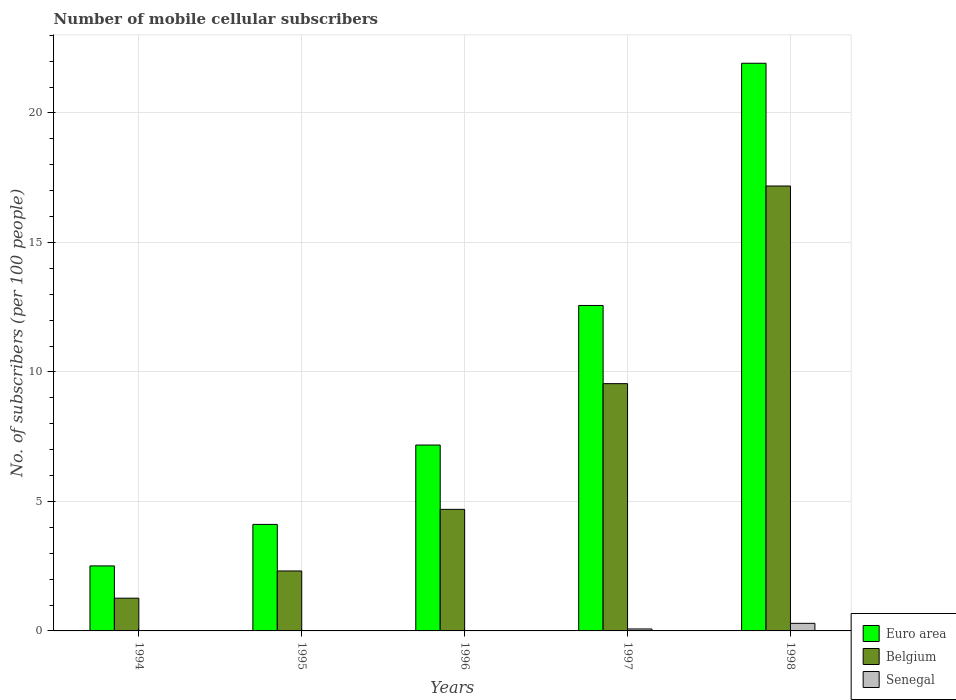How many different coloured bars are there?
Provide a succinct answer. 3. How many groups of bars are there?
Offer a terse response. 5. How many bars are there on the 4th tick from the left?
Your answer should be very brief. 3. How many bars are there on the 5th tick from the right?
Offer a very short reply. 3. What is the label of the 1st group of bars from the left?
Your response must be concise. 1994. What is the number of mobile cellular subscribers in Belgium in 1997?
Provide a short and direct response. 9.55. Across all years, what is the maximum number of mobile cellular subscribers in Senegal?
Provide a short and direct response. 0.29. Across all years, what is the minimum number of mobile cellular subscribers in Senegal?
Ensure brevity in your answer.  0. What is the total number of mobile cellular subscribers in Belgium in the graph?
Offer a very short reply. 35. What is the difference between the number of mobile cellular subscribers in Euro area in 1994 and that in 1998?
Provide a succinct answer. -19.41. What is the difference between the number of mobile cellular subscribers in Belgium in 1998 and the number of mobile cellular subscribers in Euro area in 1996?
Your answer should be compact. 10. What is the average number of mobile cellular subscribers in Euro area per year?
Offer a terse response. 9.66. In the year 1995, what is the difference between the number of mobile cellular subscribers in Belgium and number of mobile cellular subscribers in Euro area?
Offer a terse response. -1.8. In how many years, is the number of mobile cellular subscribers in Senegal greater than 19?
Provide a succinct answer. 0. What is the ratio of the number of mobile cellular subscribers in Belgium in 1995 to that in 1998?
Provide a succinct answer. 0.13. Is the difference between the number of mobile cellular subscribers in Belgium in 1995 and 1997 greater than the difference between the number of mobile cellular subscribers in Euro area in 1995 and 1997?
Keep it short and to the point. Yes. What is the difference between the highest and the second highest number of mobile cellular subscribers in Senegal?
Provide a short and direct response. 0.22. What is the difference between the highest and the lowest number of mobile cellular subscribers in Euro area?
Keep it short and to the point. 19.41. In how many years, is the number of mobile cellular subscribers in Euro area greater than the average number of mobile cellular subscribers in Euro area taken over all years?
Your answer should be very brief. 2. Is the sum of the number of mobile cellular subscribers in Belgium in 1995 and 1998 greater than the maximum number of mobile cellular subscribers in Senegal across all years?
Provide a short and direct response. Yes. What does the 1st bar from the right in 1994 represents?
Your answer should be very brief. Senegal. Is it the case that in every year, the sum of the number of mobile cellular subscribers in Senegal and number of mobile cellular subscribers in Belgium is greater than the number of mobile cellular subscribers in Euro area?
Provide a succinct answer. No. How many bars are there?
Your response must be concise. 15. How many years are there in the graph?
Give a very brief answer. 5. Are the values on the major ticks of Y-axis written in scientific E-notation?
Give a very brief answer. No. How are the legend labels stacked?
Provide a succinct answer. Vertical. What is the title of the graph?
Your answer should be very brief. Number of mobile cellular subscribers. What is the label or title of the Y-axis?
Offer a very short reply. No. of subscribers (per 100 people). What is the No. of subscribers (per 100 people) in Euro area in 1994?
Your response must be concise. 2.51. What is the No. of subscribers (per 100 people) of Belgium in 1994?
Provide a short and direct response. 1.26. What is the No. of subscribers (per 100 people) in Senegal in 1994?
Give a very brief answer. 0. What is the No. of subscribers (per 100 people) in Euro area in 1995?
Give a very brief answer. 4.11. What is the No. of subscribers (per 100 people) of Belgium in 1995?
Ensure brevity in your answer.  2.32. What is the No. of subscribers (per 100 people) in Senegal in 1995?
Make the answer very short. 0. What is the No. of subscribers (per 100 people) in Euro area in 1996?
Your response must be concise. 7.18. What is the No. of subscribers (per 100 people) of Belgium in 1996?
Your answer should be very brief. 4.69. What is the No. of subscribers (per 100 people) of Senegal in 1996?
Offer a very short reply. 0.02. What is the No. of subscribers (per 100 people) of Euro area in 1997?
Your response must be concise. 12.57. What is the No. of subscribers (per 100 people) of Belgium in 1997?
Keep it short and to the point. 9.55. What is the No. of subscribers (per 100 people) of Senegal in 1997?
Provide a short and direct response. 0.08. What is the No. of subscribers (per 100 people) of Euro area in 1998?
Make the answer very short. 21.92. What is the No. of subscribers (per 100 people) in Belgium in 1998?
Make the answer very short. 17.18. What is the No. of subscribers (per 100 people) of Senegal in 1998?
Give a very brief answer. 0.29. Across all years, what is the maximum No. of subscribers (per 100 people) in Euro area?
Your answer should be very brief. 21.92. Across all years, what is the maximum No. of subscribers (per 100 people) in Belgium?
Your response must be concise. 17.18. Across all years, what is the maximum No. of subscribers (per 100 people) of Senegal?
Your answer should be very brief. 0.29. Across all years, what is the minimum No. of subscribers (per 100 people) in Euro area?
Keep it short and to the point. 2.51. Across all years, what is the minimum No. of subscribers (per 100 people) of Belgium?
Ensure brevity in your answer.  1.26. Across all years, what is the minimum No. of subscribers (per 100 people) in Senegal?
Provide a succinct answer. 0. What is the total No. of subscribers (per 100 people) of Euro area in the graph?
Keep it short and to the point. 48.29. What is the total No. of subscribers (per 100 people) in Belgium in the graph?
Your response must be concise. 35. What is the total No. of subscribers (per 100 people) in Senegal in the graph?
Make the answer very short. 0.39. What is the difference between the No. of subscribers (per 100 people) of Euro area in 1994 and that in 1995?
Make the answer very short. -1.6. What is the difference between the No. of subscribers (per 100 people) of Belgium in 1994 and that in 1995?
Your response must be concise. -1.05. What is the difference between the No. of subscribers (per 100 people) in Senegal in 1994 and that in 1995?
Your response must be concise. -0. What is the difference between the No. of subscribers (per 100 people) of Euro area in 1994 and that in 1996?
Make the answer very short. -4.67. What is the difference between the No. of subscribers (per 100 people) in Belgium in 1994 and that in 1996?
Your answer should be compact. -3.43. What is the difference between the No. of subscribers (per 100 people) of Senegal in 1994 and that in 1996?
Provide a short and direct response. -0.01. What is the difference between the No. of subscribers (per 100 people) in Euro area in 1994 and that in 1997?
Offer a terse response. -10.06. What is the difference between the No. of subscribers (per 100 people) of Belgium in 1994 and that in 1997?
Offer a terse response. -8.28. What is the difference between the No. of subscribers (per 100 people) in Senegal in 1994 and that in 1997?
Provide a short and direct response. -0.07. What is the difference between the No. of subscribers (per 100 people) of Euro area in 1994 and that in 1998?
Provide a succinct answer. -19.41. What is the difference between the No. of subscribers (per 100 people) of Belgium in 1994 and that in 1998?
Your response must be concise. -15.92. What is the difference between the No. of subscribers (per 100 people) in Senegal in 1994 and that in 1998?
Give a very brief answer. -0.29. What is the difference between the No. of subscribers (per 100 people) in Euro area in 1995 and that in 1996?
Your answer should be compact. -3.06. What is the difference between the No. of subscribers (per 100 people) of Belgium in 1995 and that in 1996?
Provide a succinct answer. -2.38. What is the difference between the No. of subscribers (per 100 people) in Senegal in 1995 and that in 1996?
Keep it short and to the point. -0.01. What is the difference between the No. of subscribers (per 100 people) of Euro area in 1995 and that in 1997?
Give a very brief answer. -8.45. What is the difference between the No. of subscribers (per 100 people) in Belgium in 1995 and that in 1997?
Ensure brevity in your answer.  -7.23. What is the difference between the No. of subscribers (per 100 people) in Senegal in 1995 and that in 1997?
Give a very brief answer. -0.07. What is the difference between the No. of subscribers (per 100 people) in Euro area in 1995 and that in 1998?
Offer a terse response. -17.81. What is the difference between the No. of subscribers (per 100 people) of Belgium in 1995 and that in 1998?
Provide a succinct answer. -14.86. What is the difference between the No. of subscribers (per 100 people) in Senegal in 1995 and that in 1998?
Provide a succinct answer. -0.29. What is the difference between the No. of subscribers (per 100 people) in Euro area in 1996 and that in 1997?
Ensure brevity in your answer.  -5.39. What is the difference between the No. of subscribers (per 100 people) in Belgium in 1996 and that in 1997?
Provide a succinct answer. -4.85. What is the difference between the No. of subscribers (per 100 people) in Senegal in 1996 and that in 1997?
Your answer should be compact. -0.06. What is the difference between the No. of subscribers (per 100 people) of Euro area in 1996 and that in 1998?
Provide a short and direct response. -14.74. What is the difference between the No. of subscribers (per 100 people) in Belgium in 1996 and that in 1998?
Provide a succinct answer. -12.49. What is the difference between the No. of subscribers (per 100 people) in Senegal in 1996 and that in 1998?
Your response must be concise. -0.28. What is the difference between the No. of subscribers (per 100 people) in Euro area in 1997 and that in 1998?
Ensure brevity in your answer.  -9.35. What is the difference between the No. of subscribers (per 100 people) of Belgium in 1997 and that in 1998?
Ensure brevity in your answer.  -7.63. What is the difference between the No. of subscribers (per 100 people) in Senegal in 1997 and that in 1998?
Your answer should be very brief. -0.22. What is the difference between the No. of subscribers (per 100 people) of Euro area in 1994 and the No. of subscribers (per 100 people) of Belgium in 1995?
Offer a terse response. 0.2. What is the difference between the No. of subscribers (per 100 people) of Euro area in 1994 and the No. of subscribers (per 100 people) of Senegal in 1995?
Keep it short and to the point. 2.51. What is the difference between the No. of subscribers (per 100 people) in Belgium in 1994 and the No. of subscribers (per 100 people) in Senegal in 1995?
Provide a short and direct response. 1.26. What is the difference between the No. of subscribers (per 100 people) in Euro area in 1994 and the No. of subscribers (per 100 people) in Belgium in 1996?
Keep it short and to the point. -2.18. What is the difference between the No. of subscribers (per 100 people) of Euro area in 1994 and the No. of subscribers (per 100 people) of Senegal in 1996?
Offer a very short reply. 2.49. What is the difference between the No. of subscribers (per 100 people) of Belgium in 1994 and the No. of subscribers (per 100 people) of Senegal in 1996?
Give a very brief answer. 1.25. What is the difference between the No. of subscribers (per 100 people) in Euro area in 1994 and the No. of subscribers (per 100 people) in Belgium in 1997?
Offer a terse response. -7.04. What is the difference between the No. of subscribers (per 100 people) of Euro area in 1994 and the No. of subscribers (per 100 people) of Senegal in 1997?
Provide a short and direct response. 2.43. What is the difference between the No. of subscribers (per 100 people) of Belgium in 1994 and the No. of subscribers (per 100 people) of Senegal in 1997?
Give a very brief answer. 1.19. What is the difference between the No. of subscribers (per 100 people) in Euro area in 1994 and the No. of subscribers (per 100 people) in Belgium in 1998?
Make the answer very short. -14.67. What is the difference between the No. of subscribers (per 100 people) in Euro area in 1994 and the No. of subscribers (per 100 people) in Senegal in 1998?
Make the answer very short. 2.22. What is the difference between the No. of subscribers (per 100 people) in Belgium in 1994 and the No. of subscribers (per 100 people) in Senegal in 1998?
Make the answer very short. 0.97. What is the difference between the No. of subscribers (per 100 people) in Euro area in 1995 and the No. of subscribers (per 100 people) in Belgium in 1996?
Ensure brevity in your answer.  -0.58. What is the difference between the No. of subscribers (per 100 people) of Euro area in 1995 and the No. of subscribers (per 100 people) of Senegal in 1996?
Keep it short and to the point. 4.1. What is the difference between the No. of subscribers (per 100 people) in Belgium in 1995 and the No. of subscribers (per 100 people) in Senegal in 1996?
Your answer should be compact. 2.3. What is the difference between the No. of subscribers (per 100 people) in Euro area in 1995 and the No. of subscribers (per 100 people) in Belgium in 1997?
Provide a short and direct response. -5.43. What is the difference between the No. of subscribers (per 100 people) of Euro area in 1995 and the No. of subscribers (per 100 people) of Senegal in 1997?
Your answer should be very brief. 4.04. What is the difference between the No. of subscribers (per 100 people) of Belgium in 1995 and the No. of subscribers (per 100 people) of Senegal in 1997?
Keep it short and to the point. 2.24. What is the difference between the No. of subscribers (per 100 people) of Euro area in 1995 and the No. of subscribers (per 100 people) of Belgium in 1998?
Your response must be concise. -13.07. What is the difference between the No. of subscribers (per 100 people) of Euro area in 1995 and the No. of subscribers (per 100 people) of Senegal in 1998?
Offer a very short reply. 3.82. What is the difference between the No. of subscribers (per 100 people) in Belgium in 1995 and the No. of subscribers (per 100 people) in Senegal in 1998?
Ensure brevity in your answer.  2.02. What is the difference between the No. of subscribers (per 100 people) in Euro area in 1996 and the No. of subscribers (per 100 people) in Belgium in 1997?
Provide a succinct answer. -2.37. What is the difference between the No. of subscribers (per 100 people) in Euro area in 1996 and the No. of subscribers (per 100 people) in Senegal in 1997?
Give a very brief answer. 7.1. What is the difference between the No. of subscribers (per 100 people) of Belgium in 1996 and the No. of subscribers (per 100 people) of Senegal in 1997?
Provide a short and direct response. 4.62. What is the difference between the No. of subscribers (per 100 people) of Euro area in 1996 and the No. of subscribers (per 100 people) of Belgium in 1998?
Your answer should be very brief. -10. What is the difference between the No. of subscribers (per 100 people) in Euro area in 1996 and the No. of subscribers (per 100 people) in Senegal in 1998?
Keep it short and to the point. 6.88. What is the difference between the No. of subscribers (per 100 people) in Belgium in 1996 and the No. of subscribers (per 100 people) in Senegal in 1998?
Your answer should be compact. 4.4. What is the difference between the No. of subscribers (per 100 people) in Euro area in 1997 and the No. of subscribers (per 100 people) in Belgium in 1998?
Offer a terse response. -4.61. What is the difference between the No. of subscribers (per 100 people) of Euro area in 1997 and the No. of subscribers (per 100 people) of Senegal in 1998?
Your answer should be very brief. 12.27. What is the difference between the No. of subscribers (per 100 people) of Belgium in 1997 and the No. of subscribers (per 100 people) of Senegal in 1998?
Offer a very short reply. 9.26. What is the average No. of subscribers (per 100 people) in Euro area per year?
Keep it short and to the point. 9.66. What is the average No. of subscribers (per 100 people) of Belgium per year?
Offer a terse response. 7. What is the average No. of subscribers (per 100 people) of Senegal per year?
Provide a short and direct response. 0.08. In the year 1994, what is the difference between the No. of subscribers (per 100 people) of Euro area and No. of subscribers (per 100 people) of Belgium?
Provide a short and direct response. 1.25. In the year 1994, what is the difference between the No. of subscribers (per 100 people) in Euro area and No. of subscribers (per 100 people) in Senegal?
Your response must be concise. 2.51. In the year 1994, what is the difference between the No. of subscribers (per 100 people) in Belgium and No. of subscribers (per 100 people) in Senegal?
Keep it short and to the point. 1.26. In the year 1995, what is the difference between the No. of subscribers (per 100 people) of Euro area and No. of subscribers (per 100 people) of Belgium?
Offer a very short reply. 1.8. In the year 1995, what is the difference between the No. of subscribers (per 100 people) of Euro area and No. of subscribers (per 100 people) of Senegal?
Ensure brevity in your answer.  4.11. In the year 1995, what is the difference between the No. of subscribers (per 100 people) of Belgium and No. of subscribers (per 100 people) of Senegal?
Provide a succinct answer. 2.31. In the year 1996, what is the difference between the No. of subscribers (per 100 people) of Euro area and No. of subscribers (per 100 people) of Belgium?
Offer a very short reply. 2.48. In the year 1996, what is the difference between the No. of subscribers (per 100 people) in Euro area and No. of subscribers (per 100 people) in Senegal?
Your answer should be very brief. 7.16. In the year 1996, what is the difference between the No. of subscribers (per 100 people) in Belgium and No. of subscribers (per 100 people) in Senegal?
Your answer should be compact. 4.68. In the year 1997, what is the difference between the No. of subscribers (per 100 people) in Euro area and No. of subscribers (per 100 people) in Belgium?
Your answer should be compact. 3.02. In the year 1997, what is the difference between the No. of subscribers (per 100 people) of Euro area and No. of subscribers (per 100 people) of Senegal?
Offer a terse response. 12.49. In the year 1997, what is the difference between the No. of subscribers (per 100 people) of Belgium and No. of subscribers (per 100 people) of Senegal?
Ensure brevity in your answer.  9.47. In the year 1998, what is the difference between the No. of subscribers (per 100 people) in Euro area and No. of subscribers (per 100 people) in Belgium?
Keep it short and to the point. 4.74. In the year 1998, what is the difference between the No. of subscribers (per 100 people) in Euro area and No. of subscribers (per 100 people) in Senegal?
Offer a very short reply. 21.63. In the year 1998, what is the difference between the No. of subscribers (per 100 people) of Belgium and No. of subscribers (per 100 people) of Senegal?
Offer a terse response. 16.89. What is the ratio of the No. of subscribers (per 100 people) of Euro area in 1994 to that in 1995?
Your answer should be compact. 0.61. What is the ratio of the No. of subscribers (per 100 people) of Belgium in 1994 to that in 1995?
Your response must be concise. 0.55. What is the ratio of the No. of subscribers (per 100 people) in Senegal in 1994 to that in 1995?
Keep it short and to the point. 0.83. What is the ratio of the No. of subscribers (per 100 people) of Euro area in 1994 to that in 1996?
Your answer should be very brief. 0.35. What is the ratio of the No. of subscribers (per 100 people) in Belgium in 1994 to that in 1996?
Your answer should be compact. 0.27. What is the ratio of the No. of subscribers (per 100 people) of Senegal in 1994 to that in 1996?
Keep it short and to the point. 0.07. What is the ratio of the No. of subscribers (per 100 people) in Euro area in 1994 to that in 1997?
Ensure brevity in your answer.  0.2. What is the ratio of the No. of subscribers (per 100 people) of Belgium in 1994 to that in 1997?
Ensure brevity in your answer.  0.13. What is the ratio of the No. of subscribers (per 100 people) in Senegal in 1994 to that in 1997?
Your answer should be compact. 0.02. What is the ratio of the No. of subscribers (per 100 people) of Euro area in 1994 to that in 1998?
Ensure brevity in your answer.  0.11. What is the ratio of the No. of subscribers (per 100 people) of Belgium in 1994 to that in 1998?
Your response must be concise. 0.07. What is the ratio of the No. of subscribers (per 100 people) of Senegal in 1994 to that in 1998?
Make the answer very short. 0. What is the ratio of the No. of subscribers (per 100 people) of Euro area in 1995 to that in 1996?
Provide a succinct answer. 0.57. What is the ratio of the No. of subscribers (per 100 people) in Belgium in 1995 to that in 1996?
Keep it short and to the point. 0.49. What is the ratio of the No. of subscribers (per 100 people) in Senegal in 1995 to that in 1996?
Provide a succinct answer. 0.09. What is the ratio of the No. of subscribers (per 100 people) of Euro area in 1995 to that in 1997?
Your answer should be compact. 0.33. What is the ratio of the No. of subscribers (per 100 people) in Belgium in 1995 to that in 1997?
Provide a succinct answer. 0.24. What is the ratio of the No. of subscribers (per 100 people) of Senegal in 1995 to that in 1997?
Make the answer very short. 0.02. What is the ratio of the No. of subscribers (per 100 people) of Euro area in 1995 to that in 1998?
Provide a succinct answer. 0.19. What is the ratio of the No. of subscribers (per 100 people) of Belgium in 1995 to that in 1998?
Offer a very short reply. 0.13. What is the ratio of the No. of subscribers (per 100 people) in Senegal in 1995 to that in 1998?
Offer a terse response. 0. What is the ratio of the No. of subscribers (per 100 people) of Euro area in 1996 to that in 1997?
Ensure brevity in your answer.  0.57. What is the ratio of the No. of subscribers (per 100 people) in Belgium in 1996 to that in 1997?
Your answer should be compact. 0.49. What is the ratio of the No. of subscribers (per 100 people) in Senegal in 1996 to that in 1997?
Offer a terse response. 0.21. What is the ratio of the No. of subscribers (per 100 people) of Euro area in 1996 to that in 1998?
Your answer should be compact. 0.33. What is the ratio of the No. of subscribers (per 100 people) of Belgium in 1996 to that in 1998?
Your answer should be very brief. 0.27. What is the ratio of the No. of subscribers (per 100 people) in Senegal in 1996 to that in 1998?
Provide a short and direct response. 0.05. What is the ratio of the No. of subscribers (per 100 people) in Euro area in 1997 to that in 1998?
Provide a short and direct response. 0.57. What is the ratio of the No. of subscribers (per 100 people) of Belgium in 1997 to that in 1998?
Ensure brevity in your answer.  0.56. What is the ratio of the No. of subscribers (per 100 people) in Senegal in 1997 to that in 1998?
Offer a very short reply. 0.26. What is the difference between the highest and the second highest No. of subscribers (per 100 people) in Euro area?
Your response must be concise. 9.35. What is the difference between the highest and the second highest No. of subscribers (per 100 people) in Belgium?
Offer a very short reply. 7.63. What is the difference between the highest and the second highest No. of subscribers (per 100 people) in Senegal?
Give a very brief answer. 0.22. What is the difference between the highest and the lowest No. of subscribers (per 100 people) in Euro area?
Your response must be concise. 19.41. What is the difference between the highest and the lowest No. of subscribers (per 100 people) in Belgium?
Provide a succinct answer. 15.92. What is the difference between the highest and the lowest No. of subscribers (per 100 people) of Senegal?
Your answer should be compact. 0.29. 